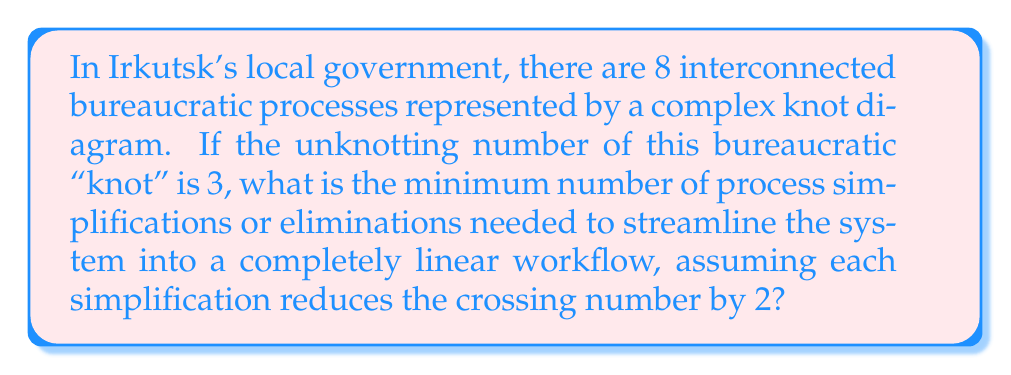Can you solve this math problem? Let's approach this step-by-step:

1) In knot theory, the unknotting number $u(K)$ is the minimum number of crossing changes needed to transform a knot $K$ into the unknot.

2) In this analogy, the bureaucratic processes form a "knot" with an unknotting number of 3. This means at least 3 changes are needed to completely simplify the system.

3) However, each simplification in our bureaucratic system reduces the crossing number by 2, not just 1 as in traditional knot theory.

4) Let $n$ be the number of simplifications needed. We need to find the smallest $n$ such that:

   $$2n \geq 3$$

5) This is because each simplification (reducing crossings by 2) should at least match the effect of one crossing change in the unknotting process.

6) Solving the inequality:

   $$n \geq \frac{3}{2} = 1.5$$

7) Since $n$ must be an integer, we round up to the nearest whole number.

Therefore, the minimum number of process simplifications needed is 2.
Answer: 2 